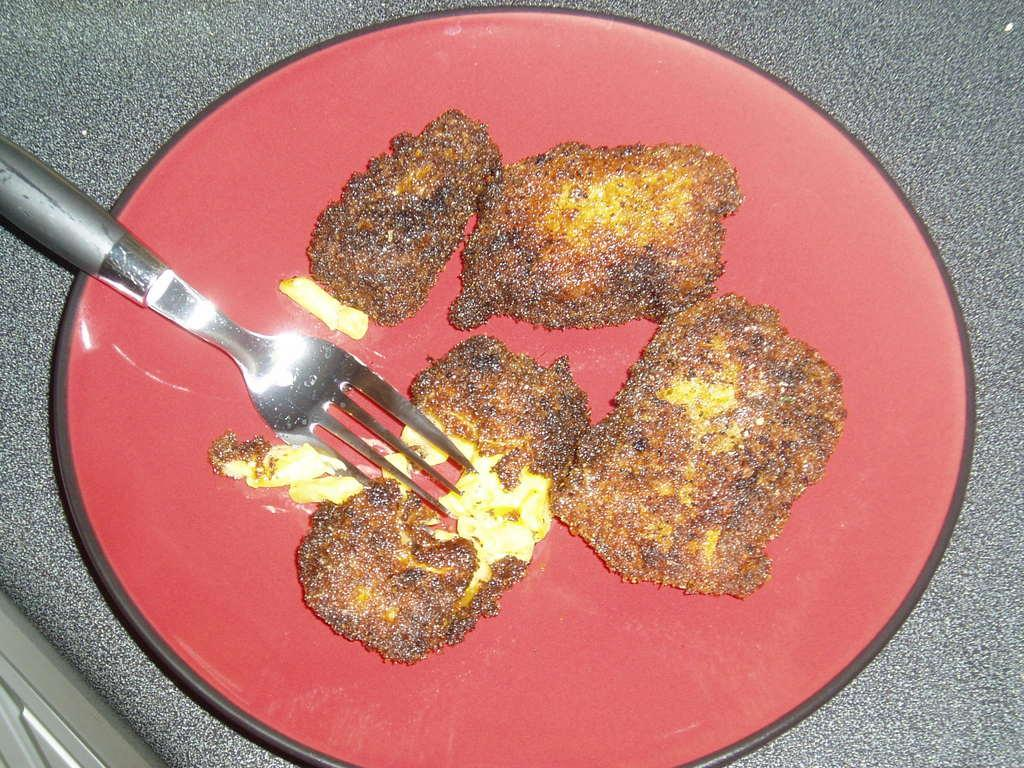What is located in the center of the image? There is a table in the center of the image. What is placed on the table? There is a plate on the table. What utensil can be seen in the plate? There is a fork in the plate. What is the purpose of the fork in the plate? The fork is likely used for eating the food items in the plate. How does the plate increase in size during the meal? The plate does not increase in size during the meal; it remains the same size. 